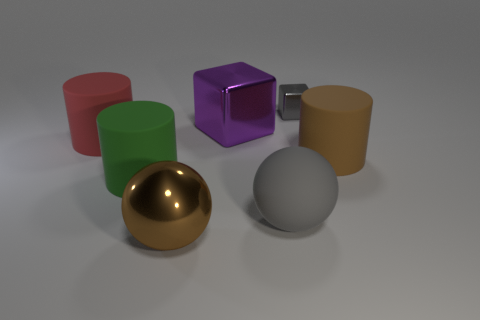Subtract all large green rubber cylinders. How many cylinders are left? 2 Add 1 big brown things. How many objects exist? 8 Subtract all balls. How many objects are left? 5 Subtract all big purple things. Subtract all gray rubber balls. How many objects are left? 5 Add 6 brown objects. How many brown objects are left? 8 Add 4 large metallic blocks. How many large metallic blocks exist? 5 Subtract 0 brown blocks. How many objects are left? 7 